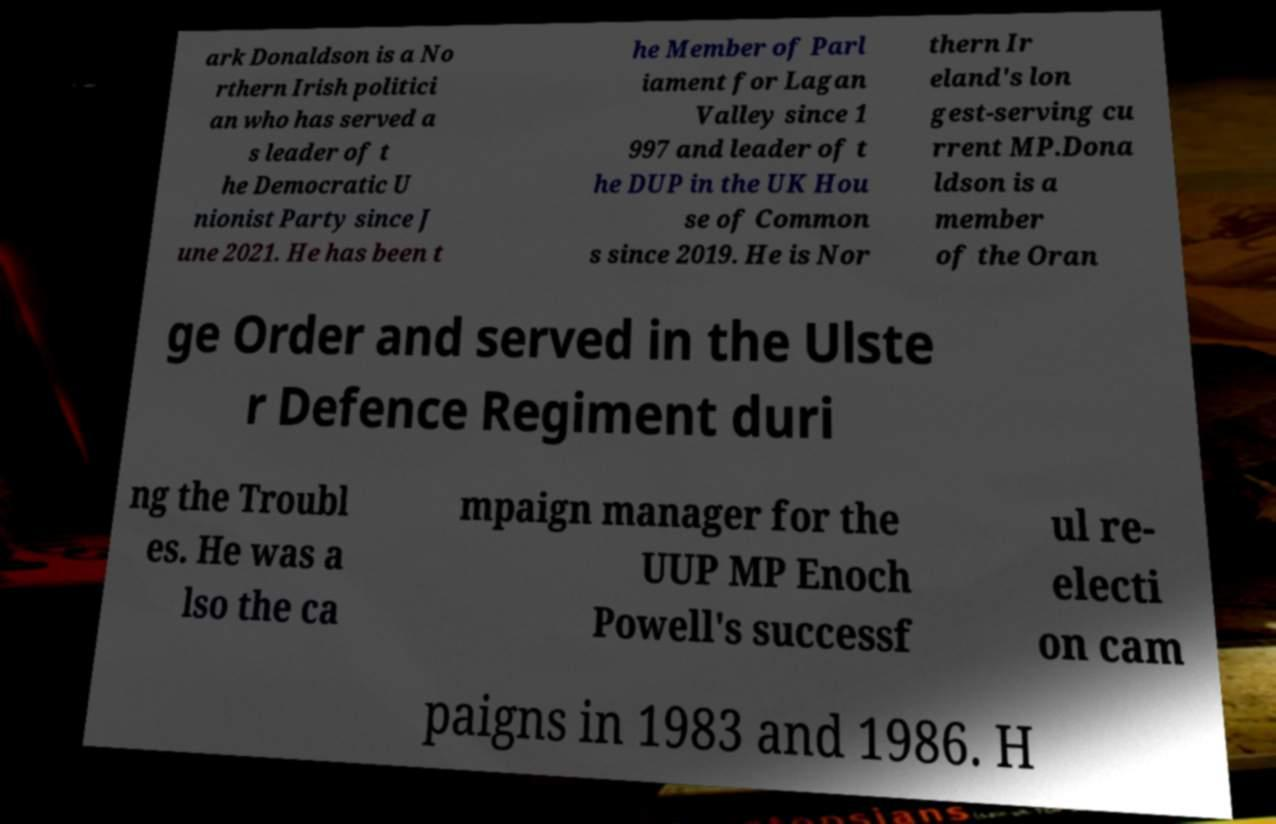Can you read and provide the text displayed in the image?This photo seems to have some interesting text. Can you extract and type it out for me? ark Donaldson is a No rthern Irish politici an who has served a s leader of t he Democratic U nionist Party since J une 2021. He has been t he Member of Parl iament for Lagan Valley since 1 997 and leader of t he DUP in the UK Hou se of Common s since 2019. He is Nor thern Ir eland's lon gest-serving cu rrent MP.Dona ldson is a member of the Oran ge Order and served in the Ulste r Defence Regiment duri ng the Troubl es. He was a lso the ca mpaign manager for the UUP MP Enoch Powell's successf ul re- electi on cam paigns in 1983 and 1986. H 